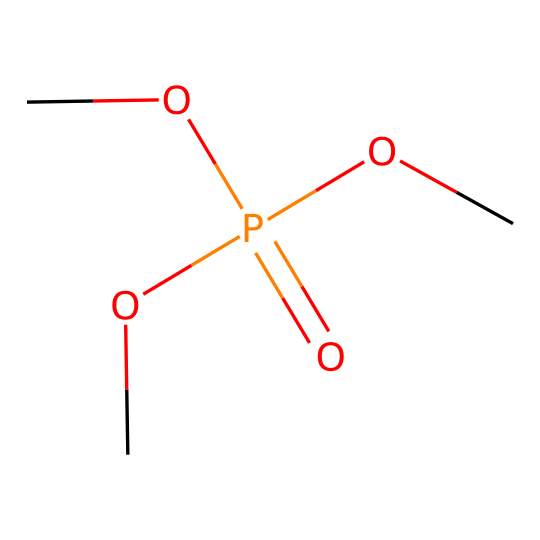What is the main functional group in this compound? The compound contains a phosphorus atom bonded to four oxygen atoms, one of which is a double bond, indicative of a phosphate functional group.
Answer: phosphate How many oxygen atoms are in this chemical structure? By analyzing the SMILES representation, we can identify that there are four oxygen atoms connected to one phosphorus atom.
Answer: four What is the total number of carbon atoms present? The chemical structure includes three methoxy groups (–OCH3), which contribute three carbon atoms, resulting in a total of three carbon atoms in the compound.
Answer: three Is this compound likely to be polar or nonpolar? The presence of multiple polar ether (methoxy) groups connected to a central phosphorus atom suggests that this compound is likely to be polar due to the difference in electronegativity between phosphorus and oxygen.
Answer: polar What role might this compound play in prop assembly? The structure suggests it is a type of adhesive or glue, as phosphorus-containing compounds are commonly used in formulations for their bonding strength and versatility.
Answer: adhesive How does the arrangement of oxygen atoms affect the properties of the compound? The arrangement of oxygen in the phosphate group, including both the double bond and single bonds, enhances the compound's ability to act as a reactive site for bonding, impacting its adhesive properties.
Answer: enhances adhesion 